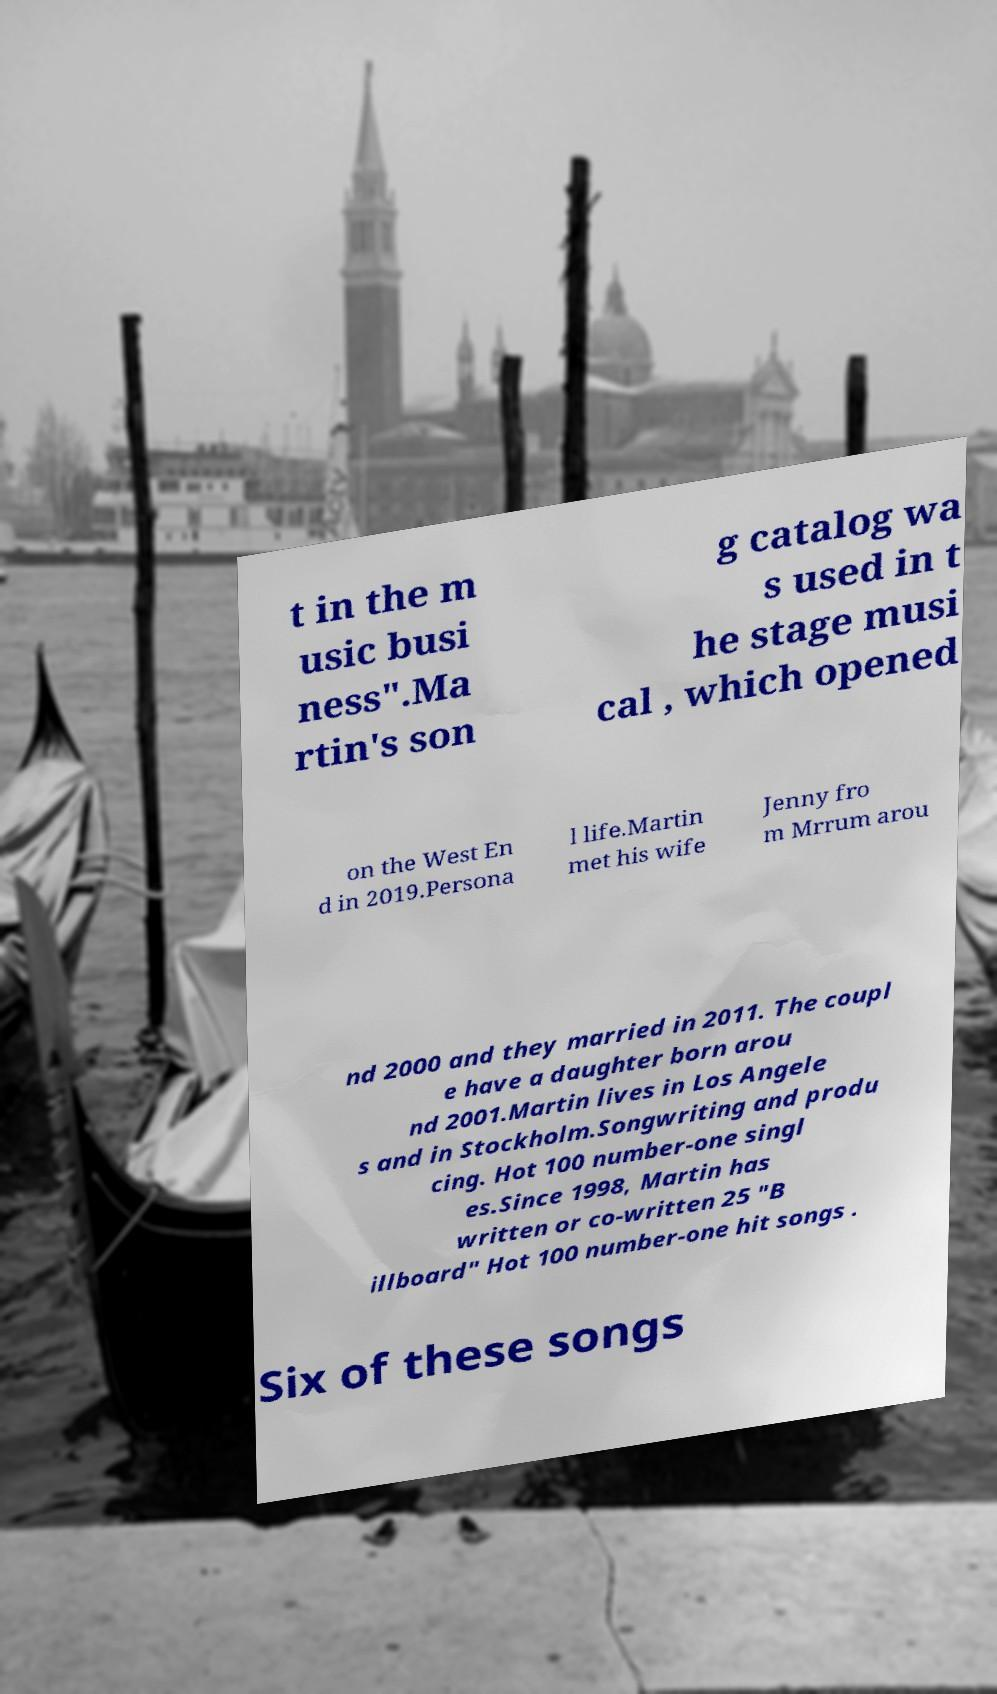Can you read and provide the text displayed in the image?This photo seems to have some interesting text. Can you extract and type it out for me? t in the m usic busi ness".Ma rtin's son g catalog wa s used in t he stage musi cal , which opened on the West En d in 2019.Persona l life.Martin met his wife Jenny fro m Mrrum arou nd 2000 and they married in 2011. The coupl e have a daughter born arou nd 2001.Martin lives in Los Angele s and in Stockholm.Songwriting and produ cing. Hot 100 number-one singl es.Since 1998, Martin has written or co-written 25 "B illboard" Hot 100 number-one hit songs . Six of these songs 